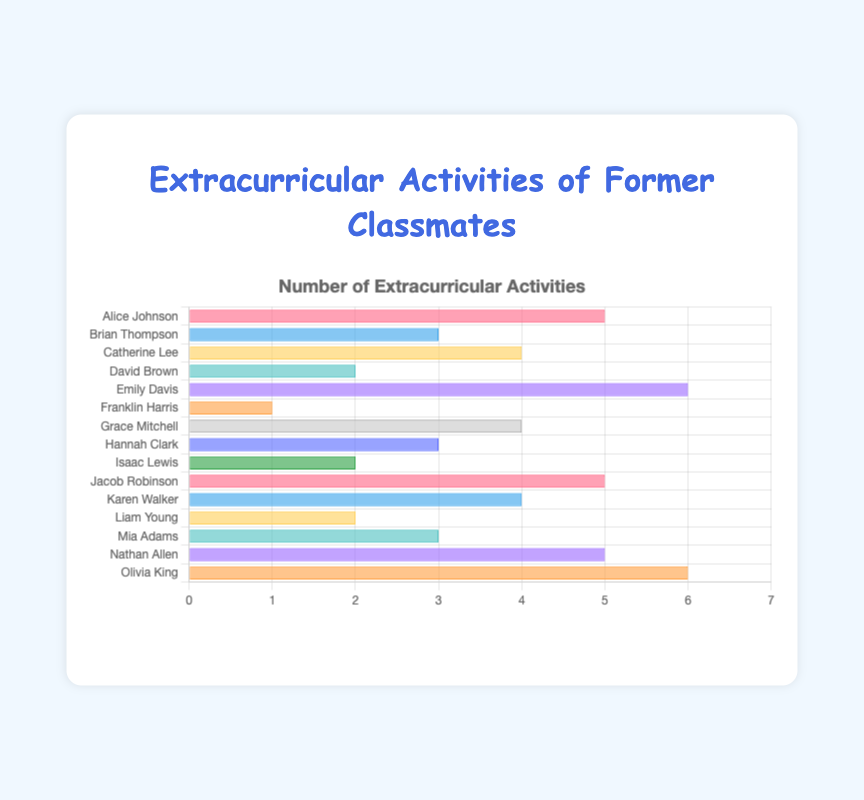Who participated in the most number of activities? Emily Davis and Olivia King have the highest bars, each reaching 6.
Answer: Emily Davis and Olivia King Which former classmate participated in just 1 activity? The bar representing Franklin Harris is the shortest and reaches only 1.
Answer: Franklin Harris How many classmates participated in exactly 4 activities? We need to count the bars that reach 4: Catherine Lee, Grace Mitchell, and Karen Walker.
Answer: 3 What is the average number of activities participated in by all classmates? Sum the values (5 + 3 + 4 + 2 + 6 + 1 + 4 + 3 + 2 + 5 + 4 + 2 + 3 + 5 + 6) = 55. There are 15 classmates, so the average is 55/15 ≈ 3.67.
Answer: 3.67 What's the difference in the number of activities between David Brown and Jacob Robinson? Jacob Robinson participated in 5 activities, and David Brown in 2. The difference is 5 - 2 = 3.
Answer: 3 How many total activities did Isaac Lewis and Liam Young participate in? Both Isaac and Liam participated in 2 activities each. Total is 2 + 2 = 4.
Answer: 4 Which classmates participated in more than 4 activities? Emily Davis, Alice Johnson, Jacob Robinson, Nathan Allen, and Olivia King all have bars greater than 4. Therefore, it's 5 classmates.
Answer: 5 How many activities more did Alice Johnson participate than Franklin Harris? Alice Johnson participated in 5 activities, Franklin Harris in 1. The difference is 5 - 1 = 4.
Answer: 4 Compare the number of activities participated in by Mia Adams and Hannah Clark. Both bars show 3 activities each.
Answer: Equal 